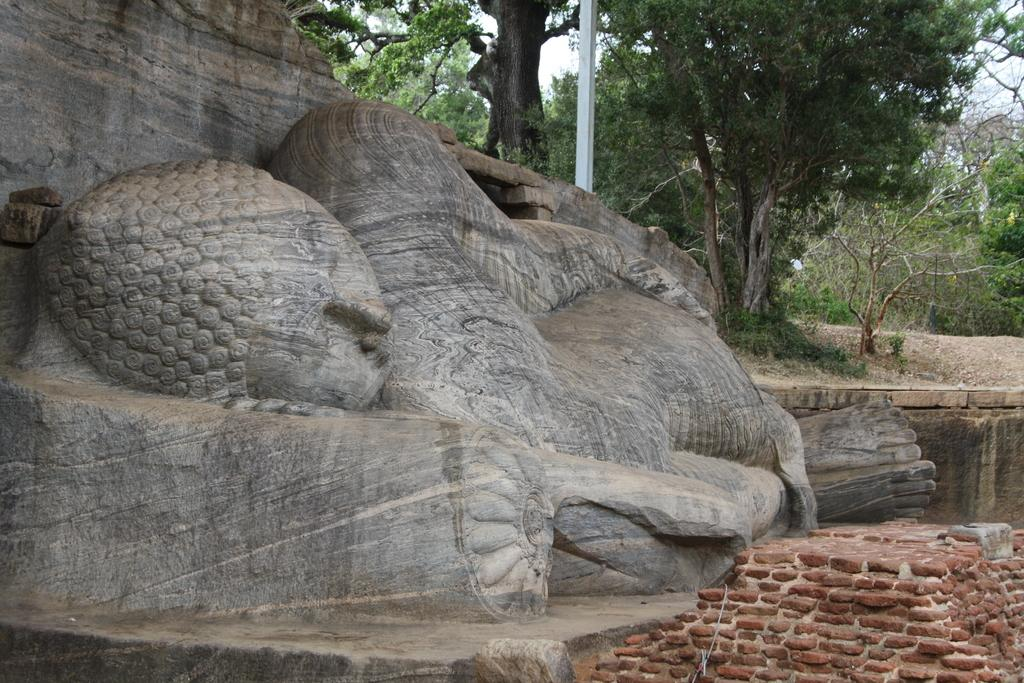What is the main subject of the image? There is a wooden carving of a person in the image. What position is the person in? The person is in a sleeping position. What can be seen in the background of the image? There are many trees and the sky visible in the background of the image. How many boys are playing with the train in the image? There is no train or boys present in the image; it features a wooden carving of a person in a sleeping position with trees and the sky in the background. 